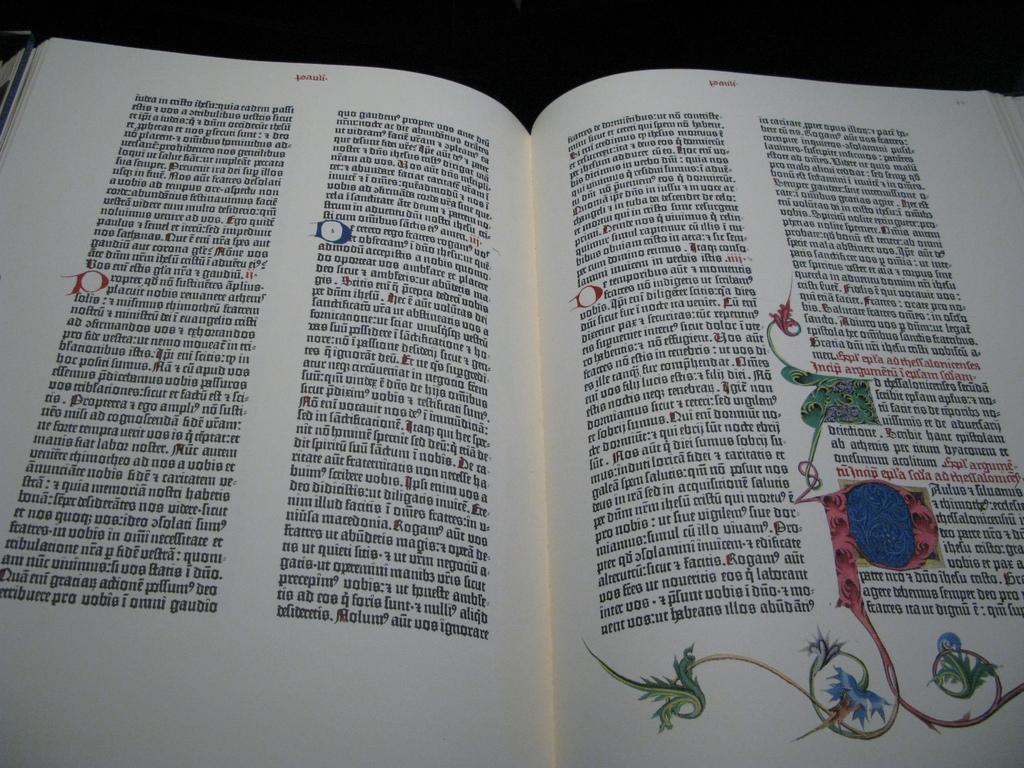Describe this image in one or two sentences. In this image, we can see a book which is opened. On the right side, we can see a painting on the book. At the top, we can see black color. 